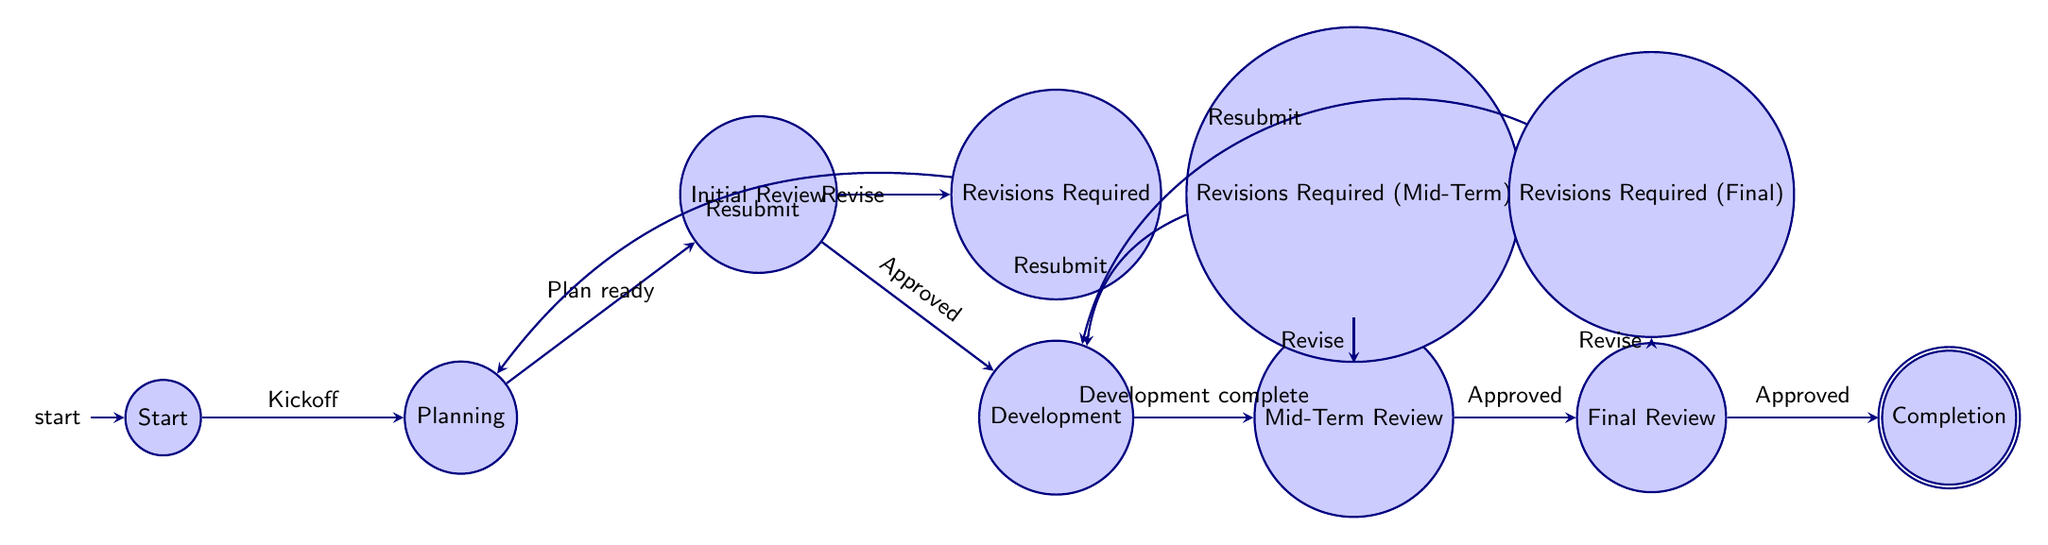What is the first node in the diagram? The diagram starts at the "Start" node, which is the first node representing the project initiation and kickoff meeting.
Answer: Start How many nodes are in the diagram? By counting each unique node displayed, there are a total of 10 nodes present in the diagram.
Answer: 10 What is the last node in the process sequence? The last node reached upon successful completion of the project is the "Completion" node, which indicates project completion and handover.
Answer: Completion Which node comes after "Initial Review"? After the "Initial Review," the next node is "Development," which indicates the start of the project development phase.
Answer: Development How many transitions are there from "Final Review"? There are two transitions from the "Final Review" node: one leading to "Revisions Required Final" and the other leading to "Completion."
Answer: 2 What happens if revisions are required after "Mid-Term Review"? If revisions are needed after the "Mid-Term Review," the process transitions to the "Revisions Required Mid-Term" node, which indicates that resubmission and development are necessary.
Answer: Revisions Required Mid-Term In which state does the project end? The project ends in the "Completion" node, indicating the final phase where the project is completed and handed over.
Answer: Completion What follows after the "Planning" node? Following the "Planning" node, once the plan is ready, it transitions to the "Initial Review" node where the project plan is reviewed by team leads.
Answer: Initial Review How many ways can the project come back to the "Planning" node? The project can return to the "Planning" node typically from the "Revisions Required" state when revisions are needed based on feedback from the initial review.
Answer: 1 